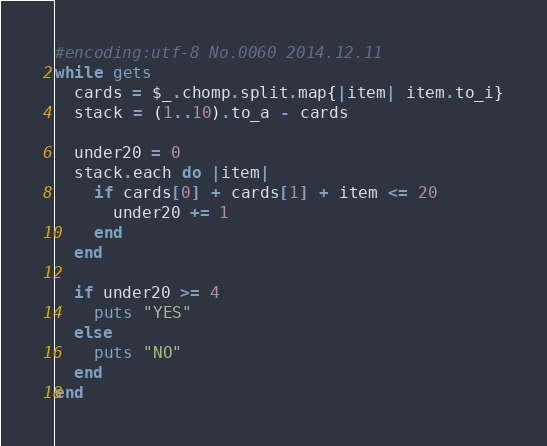<code> <loc_0><loc_0><loc_500><loc_500><_Ruby_>#encoding:utf-8 No.0060 2014.12.11
while gets
  cards = $_.chomp.split.map{|item| item.to_i}
  stack = (1..10).to_a - cards

  under20 = 0
  stack.each do |item|
    if cards[0] + cards[1] + item <= 20
      under20 += 1
    end
  end

  if under20 >= 4
    puts "YES"
  else
    puts "NO"
  end
end</code> 